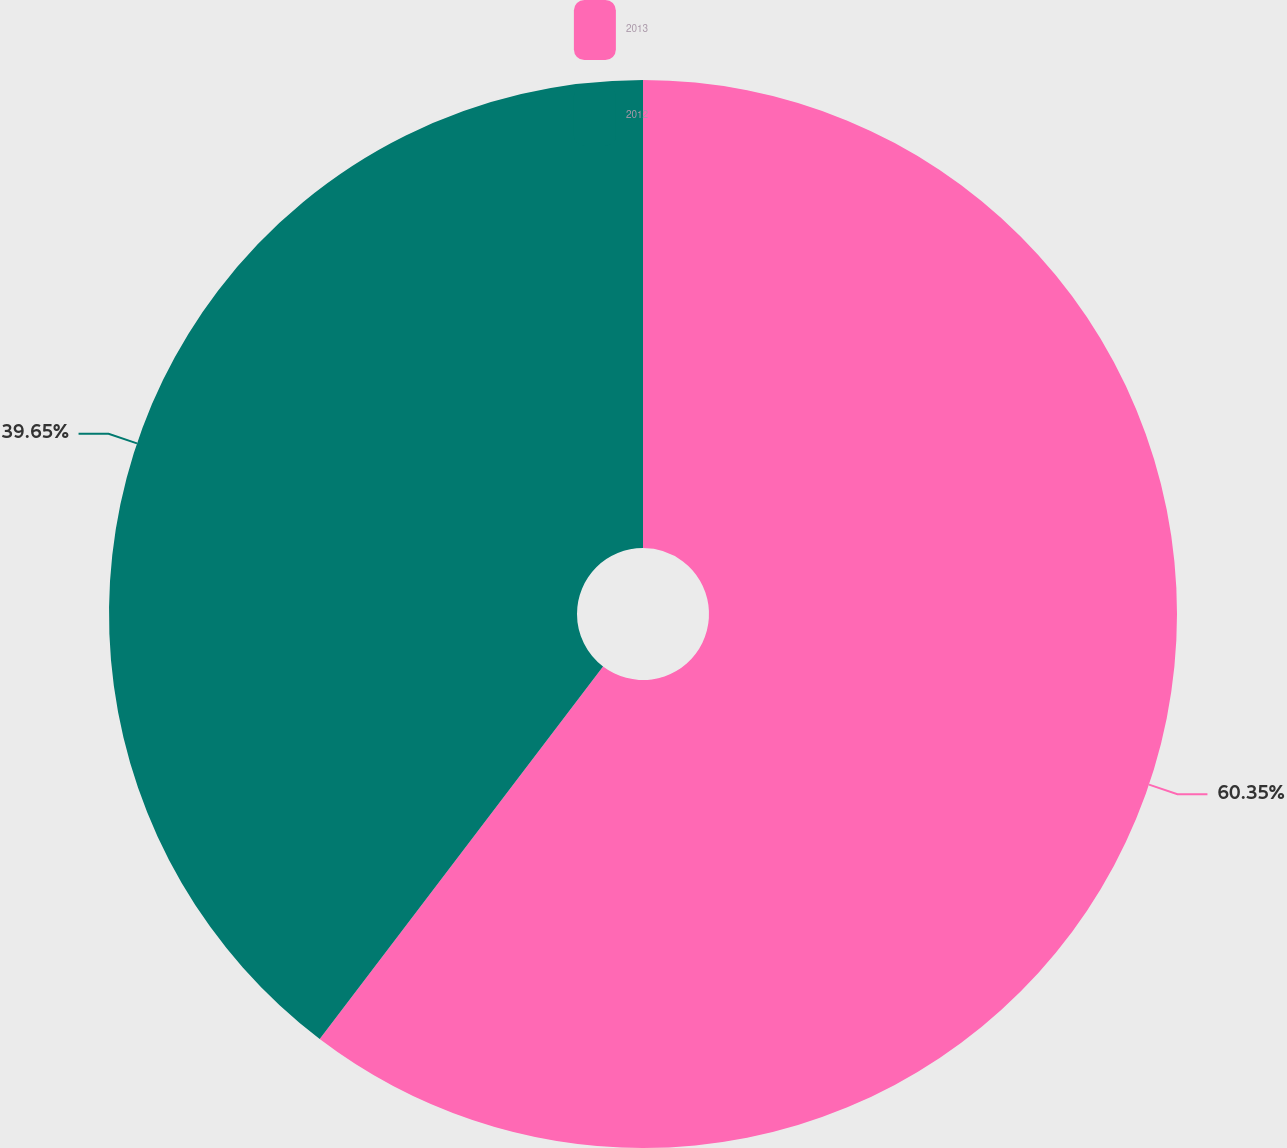Convert chart to OTSL. <chart><loc_0><loc_0><loc_500><loc_500><pie_chart><fcel>2013<fcel>2012<nl><fcel>60.35%<fcel>39.65%<nl></chart> 